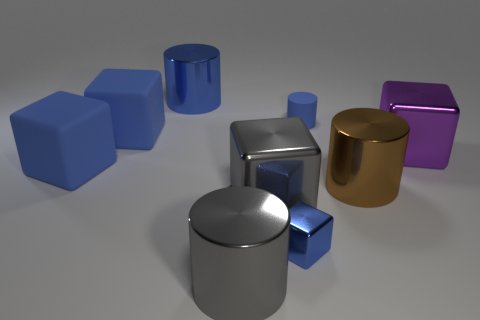Does the small cylinder have the same color as the tiny metallic thing?
Provide a succinct answer. Yes. There is a large metallic thing on the right side of the big metallic cylinder on the right side of the small blue rubber cylinder; what is its shape?
Your response must be concise. Cube. What shape is the small thing that is made of the same material as the purple cube?
Give a very brief answer. Cube. How many other objects are the same shape as the brown object?
Ensure brevity in your answer.  3. There is a brown shiny cylinder that is behind the gray cylinder; is its size the same as the big gray metal block?
Keep it short and to the point. Yes. Is the number of tiny cylinders behind the purple shiny object greater than the number of purple rubber cubes?
Give a very brief answer. Yes. There is a blue cylinder that is right of the blue metal cylinder; what number of tiny blue rubber cylinders are on the right side of it?
Keep it short and to the point. 0. Is the number of brown cylinders to the left of the tiny metallic block less than the number of blue matte cylinders?
Give a very brief answer. Yes. There is a tiny blue object behind the large gray shiny object that is right of the gray cylinder; is there a rubber cylinder on the left side of it?
Your answer should be very brief. No. Are the purple cube and the tiny blue thing that is in front of the purple object made of the same material?
Your answer should be compact. Yes. 